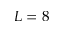Convert formula to latex. <formula><loc_0><loc_0><loc_500><loc_500>L = 8</formula> 